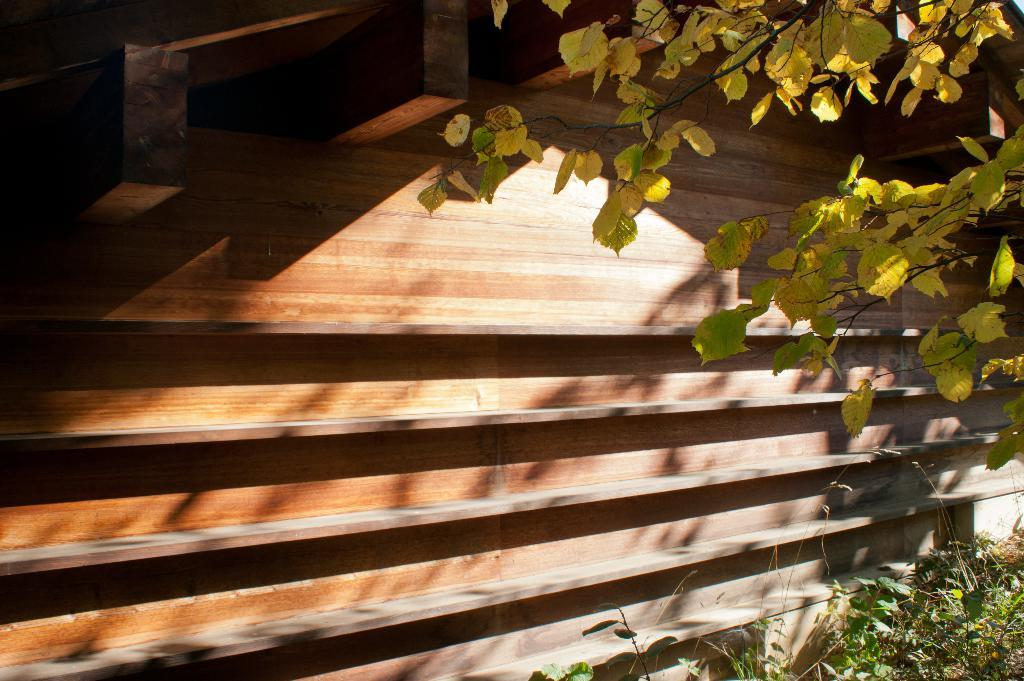What type of living organisms can be seen in the image? Plants can be seen in the image. What part of the plants is visible in the image? There are leaves of a tree visible in the image. What type of material is the wall made of in the image? There is a wooden wall in the image. What channel is the card game being broadcasted on in the image? There is no channel or card game present in the image. 